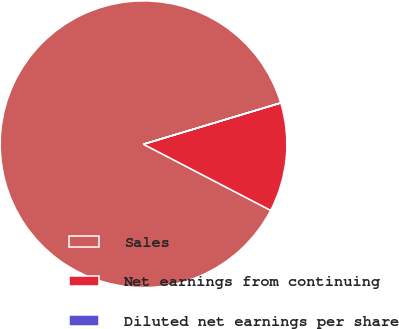Convert chart. <chart><loc_0><loc_0><loc_500><loc_500><pie_chart><fcel>Sales<fcel>Net earnings from continuing<fcel>Diluted net earnings per share<nl><fcel>87.7%<fcel>12.28%<fcel>0.02%<nl></chart> 